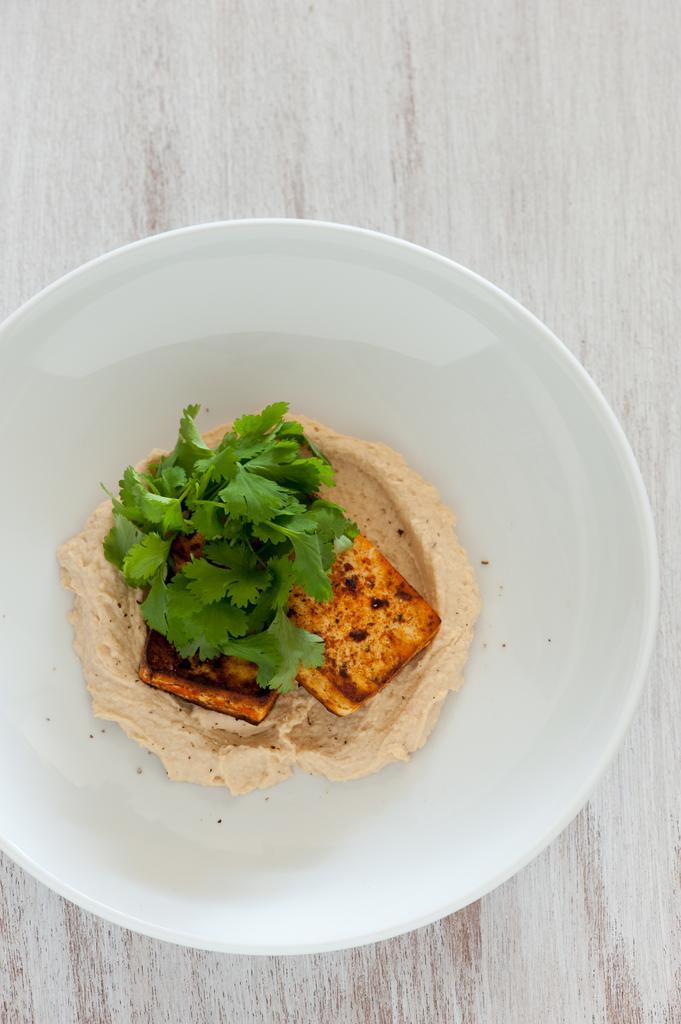Can you describe this image briefly? In this picture I can see food in the plate and a table in the background. 